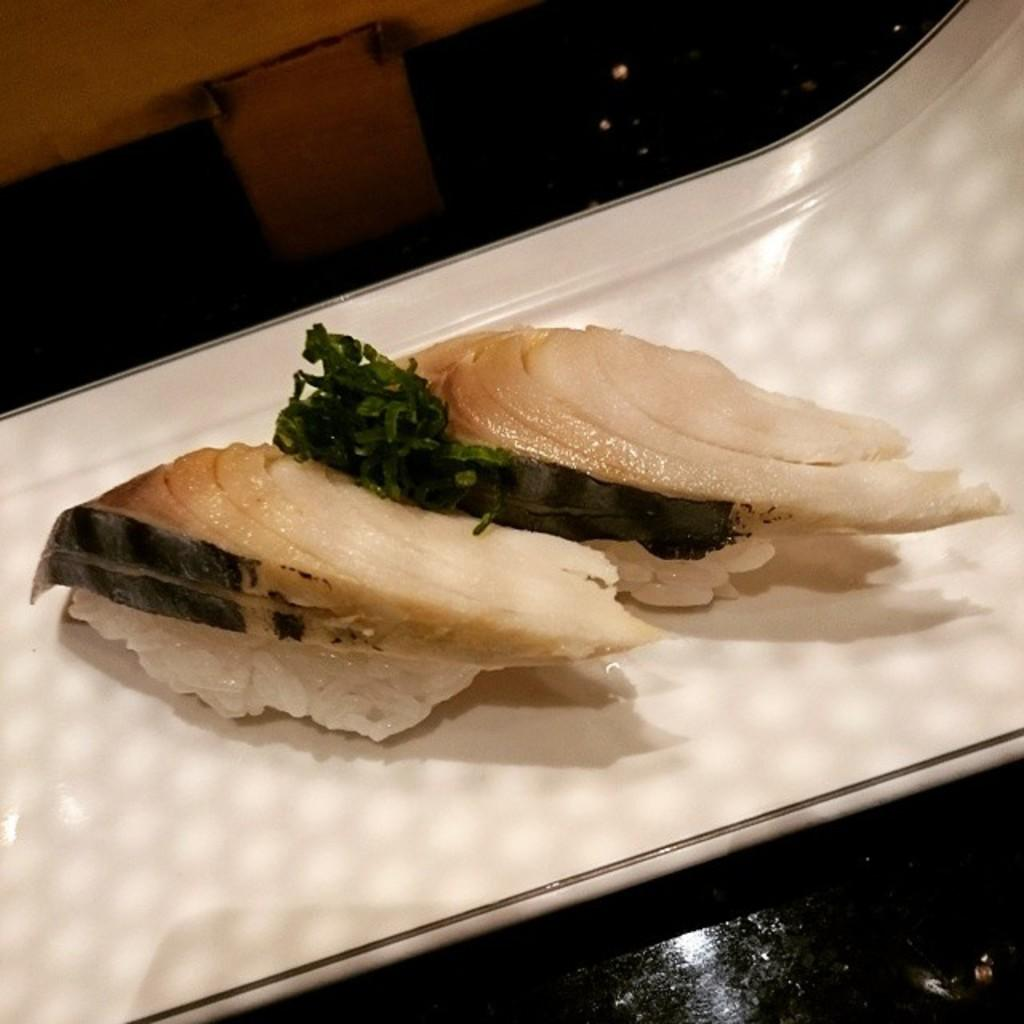What type of food items can be seen in the image? The food items in the image have white and brown colors. What other elements are present in the image besides the food items? A: There are green leaves in the image. What is the color of the surface on which the green leaves are placed? The green leaves are on a white surface. What type of island can be seen in the image? There is no island present in the image. What is the carpenter using the hammer for in the image? There is no carpenter or hammer present in the image. 